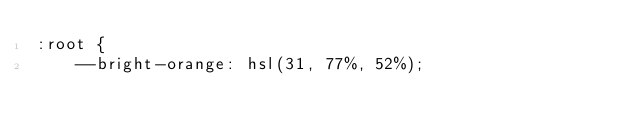<code> <loc_0><loc_0><loc_500><loc_500><_CSS_>:root {
    --bright-orange: hsl(31, 77%, 52%);</code> 